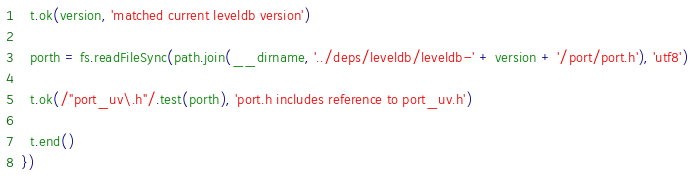Convert code to text. <code><loc_0><loc_0><loc_500><loc_500><_JavaScript_>
  t.ok(version, 'matched current leveldb version')

  porth = fs.readFileSync(path.join(__dirname, '../deps/leveldb/leveldb-' + version + '/port/port.h'), 'utf8')

  t.ok(/"port_uv\.h"/.test(porth), 'port.h includes reference to port_uv.h')

  t.end()
})
</code> 